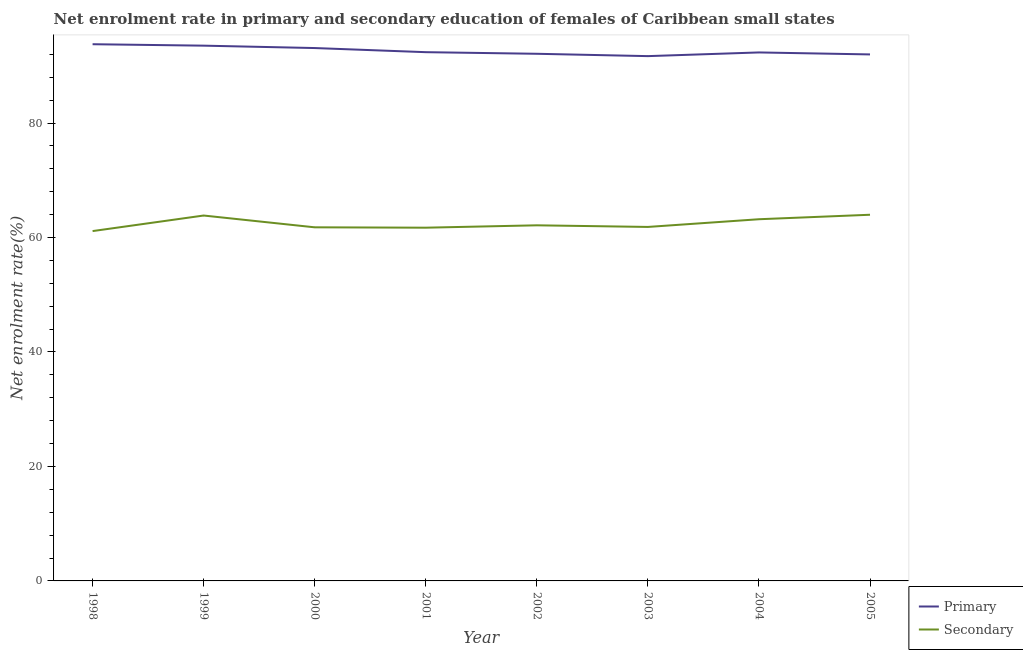Does the line corresponding to enrollment rate in primary education intersect with the line corresponding to enrollment rate in secondary education?
Provide a short and direct response. No. What is the enrollment rate in secondary education in 1999?
Your answer should be very brief. 63.84. Across all years, what is the maximum enrollment rate in primary education?
Provide a short and direct response. 93.77. Across all years, what is the minimum enrollment rate in primary education?
Give a very brief answer. 91.69. In which year was the enrollment rate in primary education maximum?
Provide a succinct answer. 1998. In which year was the enrollment rate in secondary education minimum?
Your response must be concise. 1998. What is the total enrollment rate in secondary education in the graph?
Provide a succinct answer. 499.57. What is the difference between the enrollment rate in primary education in 2004 and that in 2005?
Give a very brief answer. 0.35. What is the difference between the enrollment rate in secondary education in 1999 and the enrollment rate in primary education in 2005?
Your answer should be compact. -28.15. What is the average enrollment rate in primary education per year?
Ensure brevity in your answer.  92.61. In the year 2003, what is the difference between the enrollment rate in primary education and enrollment rate in secondary education?
Give a very brief answer. 29.84. In how many years, is the enrollment rate in primary education greater than 24 %?
Your answer should be compact. 8. What is the ratio of the enrollment rate in secondary education in 2000 to that in 2001?
Your response must be concise. 1. Is the enrollment rate in primary education in 1998 less than that in 2002?
Provide a succinct answer. No. What is the difference between the highest and the second highest enrollment rate in primary education?
Make the answer very short. 0.25. What is the difference between the highest and the lowest enrollment rate in secondary education?
Your answer should be compact. 2.85. Is the sum of the enrollment rate in secondary education in 1999 and 2003 greater than the maximum enrollment rate in primary education across all years?
Provide a succinct answer. Yes. Does the enrollment rate in primary education monotonically increase over the years?
Ensure brevity in your answer.  No. Is the enrollment rate in primary education strictly less than the enrollment rate in secondary education over the years?
Provide a succinct answer. No. How many lines are there?
Make the answer very short. 2. What is the difference between two consecutive major ticks on the Y-axis?
Your answer should be compact. 20. Are the values on the major ticks of Y-axis written in scientific E-notation?
Your response must be concise. No. Where does the legend appear in the graph?
Your response must be concise. Bottom right. What is the title of the graph?
Ensure brevity in your answer.  Net enrolment rate in primary and secondary education of females of Caribbean small states. Does "Long-term debt" appear as one of the legend labels in the graph?
Provide a short and direct response. No. What is the label or title of the X-axis?
Offer a terse response. Year. What is the label or title of the Y-axis?
Your response must be concise. Net enrolment rate(%). What is the Net enrolment rate(%) of Primary in 1998?
Keep it short and to the point. 93.77. What is the Net enrolment rate(%) in Secondary in 1998?
Provide a short and direct response. 61.12. What is the Net enrolment rate(%) of Primary in 1999?
Ensure brevity in your answer.  93.51. What is the Net enrolment rate(%) in Secondary in 1999?
Your answer should be very brief. 63.84. What is the Net enrolment rate(%) in Primary in 2000?
Give a very brief answer. 93.1. What is the Net enrolment rate(%) of Secondary in 2000?
Make the answer very short. 61.78. What is the Net enrolment rate(%) in Primary in 2001?
Offer a terse response. 92.38. What is the Net enrolment rate(%) of Secondary in 2001?
Make the answer very short. 61.71. What is the Net enrolment rate(%) of Primary in 2002?
Your answer should be compact. 92.09. What is the Net enrolment rate(%) in Secondary in 2002?
Your response must be concise. 62.13. What is the Net enrolment rate(%) in Primary in 2003?
Ensure brevity in your answer.  91.69. What is the Net enrolment rate(%) in Secondary in 2003?
Make the answer very short. 61.84. What is the Net enrolment rate(%) of Primary in 2004?
Your answer should be compact. 92.33. What is the Net enrolment rate(%) in Secondary in 2004?
Ensure brevity in your answer.  63.19. What is the Net enrolment rate(%) in Primary in 2005?
Provide a short and direct response. 91.98. What is the Net enrolment rate(%) of Secondary in 2005?
Provide a short and direct response. 63.97. Across all years, what is the maximum Net enrolment rate(%) in Primary?
Your answer should be very brief. 93.77. Across all years, what is the maximum Net enrolment rate(%) of Secondary?
Keep it short and to the point. 63.97. Across all years, what is the minimum Net enrolment rate(%) of Primary?
Provide a short and direct response. 91.69. Across all years, what is the minimum Net enrolment rate(%) in Secondary?
Make the answer very short. 61.12. What is the total Net enrolment rate(%) in Primary in the graph?
Give a very brief answer. 740.84. What is the total Net enrolment rate(%) of Secondary in the graph?
Your answer should be very brief. 499.57. What is the difference between the Net enrolment rate(%) in Primary in 1998 and that in 1999?
Give a very brief answer. 0.25. What is the difference between the Net enrolment rate(%) in Secondary in 1998 and that in 1999?
Keep it short and to the point. -2.72. What is the difference between the Net enrolment rate(%) in Primary in 1998 and that in 2000?
Your response must be concise. 0.67. What is the difference between the Net enrolment rate(%) of Secondary in 1998 and that in 2000?
Your answer should be very brief. -0.66. What is the difference between the Net enrolment rate(%) of Primary in 1998 and that in 2001?
Give a very brief answer. 1.39. What is the difference between the Net enrolment rate(%) of Secondary in 1998 and that in 2001?
Your response must be concise. -0.59. What is the difference between the Net enrolment rate(%) in Primary in 1998 and that in 2002?
Make the answer very short. 1.67. What is the difference between the Net enrolment rate(%) of Secondary in 1998 and that in 2002?
Your response must be concise. -1.01. What is the difference between the Net enrolment rate(%) of Primary in 1998 and that in 2003?
Your response must be concise. 2.08. What is the difference between the Net enrolment rate(%) of Secondary in 1998 and that in 2003?
Your answer should be compact. -0.72. What is the difference between the Net enrolment rate(%) of Primary in 1998 and that in 2004?
Provide a short and direct response. 1.44. What is the difference between the Net enrolment rate(%) in Secondary in 1998 and that in 2004?
Ensure brevity in your answer.  -2.07. What is the difference between the Net enrolment rate(%) of Primary in 1998 and that in 2005?
Your response must be concise. 1.78. What is the difference between the Net enrolment rate(%) in Secondary in 1998 and that in 2005?
Your response must be concise. -2.85. What is the difference between the Net enrolment rate(%) in Primary in 1999 and that in 2000?
Your response must be concise. 0.42. What is the difference between the Net enrolment rate(%) in Secondary in 1999 and that in 2000?
Your answer should be very brief. 2.06. What is the difference between the Net enrolment rate(%) of Primary in 1999 and that in 2001?
Your response must be concise. 1.14. What is the difference between the Net enrolment rate(%) of Secondary in 1999 and that in 2001?
Your answer should be compact. 2.12. What is the difference between the Net enrolment rate(%) of Primary in 1999 and that in 2002?
Offer a terse response. 1.42. What is the difference between the Net enrolment rate(%) of Secondary in 1999 and that in 2002?
Offer a terse response. 1.71. What is the difference between the Net enrolment rate(%) in Primary in 1999 and that in 2003?
Offer a terse response. 1.83. What is the difference between the Net enrolment rate(%) in Secondary in 1999 and that in 2003?
Ensure brevity in your answer.  1.99. What is the difference between the Net enrolment rate(%) in Primary in 1999 and that in 2004?
Offer a terse response. 1.19. What is the difference between the Net enrolment rate(%) in Secondary in 1999 and that in 2004?
Your response must be concise. 0.65. What is the difference between the Net enrolment rate(%) in Primary in 1999 and that in 2005?
Give a very brief answer. 1.53. What is the difference between the Net enrolment rate(%) in Secondary in 1999 and that in 2005?
Provide a short and direct response. -0.14. What is the difference between the Net enrolment rate(%) of Primary in 2000 and that in 2001?
Offer a very short reply. 0.72. What is the difference between the Net enrolment rate(%) in Secondary in 2000 and that in 2001?
Give a very brief answer. 0.06. What is the difference between the Net enrolment rate(%) in Primary in 2000 and that in 2002?
Offer a very short reply. 1. What is the difference between the Net enrolment rate(%) of Secondary in 2000 and that in 2002?
Make the answer very short. -0.35. What is the difference between the Net enrolment rate(%) in Primary in 2000 and that in 2003?
Offer a very short reply. 1.41. What is the difference between the Net enrolment rate(%) in Secondary in 2000 and that in 2003?
Keep it short and to the point. -0.07. What is the difference between the Net enrolment rate(%) in Primary in 2000 and that in 2004?
Provide a succinct answer. 0.77. What is the difference between the Net enrolment rate(%) of Secondary in 2000 and that in 2004?
Keep it short and to the point. -1.41. What is the difference between the Net enrolment rate(%) in Primary in 2000 and that in 2005?
Give a very brief answer. 1.11. What is the difference between the Net enrolment rate(%) of Secondary in 2000 and that in 2005?
Make the answer very short. -2.2. What is the difference between the Net enrolment rate(%) in Primary in 2001 and that in 2002?
Your answer should be compact. 0.28. What is the difference between the Net enrolment rate(%) in Secondary in 2001 and that in 2002?
Give a very brief answer. -0.42. What is the difference between the Net enrolment rate(%) of Primary in 2001 and that in 2003?
Your answer should be compact. 0.69. What is the difference between the Net enrolment rate(%) of Secondary in 2001 and that in 2003?
Your answer should be compact. -0.13. What is the difference between the Net enrolment rate(%) of Primary in 2001 and that in 2004?
Give a very brief answer. 0.05. What is the difference between the Net enrolment rate(%) in Secondary in 2001 and that in 2004?
Give a very brief answer. -1.48. What is the difference between the Net enrolment rate(%) in Primary in 2001 and that in 2005?
Ensure brevity in your answer.  0.39. What is the difference between the Net enrolment rate(%) of Secondary in 2001 and that in 2005?
Give a very brief answer. -2.26. What is the difference between the Net enrolment rate(%) of Primary in 2002 and that in 2003?
Your response must be concise. 0.41. What is the difference between the Net enrolment rate(%) in Secondary in 2002 and that in 2003?
Provide a short and direct response. 0.28. What is the difference between the Net enrolment rate(%) in Primary in 2002 and that in 2004?
Your answer should be compact. -0.23. What is the difference between the Net enrolment rate(%) in Secondary in 2002 and that in 2004?
Your response must be concise. -1.06. What is the difference between the Net enrolment rate(%) in Primary in 2002 and that in 2005?
Provide a succinct answer. 0.11. What is the difference between the Net enrolment rate(%) in Secondary in 2002 and that in 2005?
Offer a terse response. -1.85. What is the difference between the Net enrolment rate(%) in Primary in 2003 and that in 2004?
Give a very brief answer. -0.64. What is the difference between the Net enrolment rate(%) in Secondary in 2003 and that in 2004?
Your answer should be compact. -1.35. What is the difference between the Net enrolment rate(%) in Primary in 2003 and that in 2005?
Your answer should be very brief. -0.3. What is the difference between the Net enrolment rate(%) of Secondary in 2003 and that in 2005?
Keep it short and to the point. -2.13. What is the difference between the Net enrolment rate(%) of Primary in 2004 and that in 2005?
Provide a succinct answer. 0.35. What is the difference between the Net enrolment rate(%) in Secondary in 2004 and that in 2005?
Make the answer very short. -0.78. What is the difference between the Net enrolment rate(%) in Primary in 1998 and the Net enrolment rate(%) in Secondary in 1999?
Your answer should be compact. 29.93. What is the difference between the Net enrolment rate(%) of Primary in 1998 and the Net enrolment rate(%) of Secondary in 2000?
Provide a short and direct response. 31.99. What is the difference between the Net enrolment rate(%) of Primary in 1998 and the Net enrolment rate(%) of Secondary in 2001?
Keep it short and to the point. 32.05. What is the difference between the Net enrolment rate(%) in Primary in 1998 and the Net enrolment rate(%) in Secondary in 2002?
Provide a succinct answer. 31.64. What is the difference between the Net enrolment rate(%) in Primary in 1998 and the Net enrolment rate(%) in Secondary in 2003?
Your answer should be very brief. 31.92. What is the difference between the Net enrolment rate(%) of Primary in 1998 and the Net enrolment rate(%) of Secondary in 2004?
Provide a succinct answer. 30.58. What is the difference between the Net enrolment rate(%) in Primary in 1998 and the Net enrolment rate(%) in Secondary in 2005?
Your answer should be compact. 29.79. What is the difference between the Net enrolment rate(%) of Primary in 1999 and the Net enrolment rate(%) of Secondary in 2000?
Provide a short and direct response. 31.74. What is the difference between the Net enrolment rate(%) in Primary in 1999 and the Net enrolment rate(%) in Secondary in 2001?
Offer a very short reply. 31.8. What is the difference between the Net enrolment rate(%) in Primary in 1999 and the Net enrolment rate(%) in Secondary in 2002?
Make the answer very short. 31.39. What is the difference between the Net enrolment rate(%) of Primary in 1999 and the Net enrolment rate(%) of Secondary in 2003?
Make the answer very short. 31.67. What is the difference between the Net enrolment rate(%) in Primary in 1999 and the Net enrolment rate(%) in Secondary in 2004?
Keep it short and to the point. 30.32. What is the difference between the Net enrolment rate(%) of Primary in 1999 and the Net enrolment rate(%) of Secondary in 2005?
Make the answer very short. 29.54. What is the difference between the Net enrolment rate(%) of Primary in 2000 and the Net enrolment rate(%) of Secondary in 2001?
Offer a terse response. 31.39. What is the difference between the Net enrolment rate(%) of Primary in 2000 and the Net enrolment rate(%) of Secondary in 2002?
Your response must be concise. 30.97. What is the difference between the Net enrolment rate(%) in Primary in 2000 and the Net enrolment rate(%) in Secondary in 2003?
Provide a succinct answer. 31.25. What is the difference between the Net enrolment rate(%) in Primary in 2000 and the Net enrolment rate(%) in Secondary in 2004?
Provide a succinct answer. 29.91. What is the difference between the Net enrolment rate(%) of Primary in 2000 and the Net enrolment rate(%) of Secondary in 2005?
Keep it short and to the point. 29.12. What is the difference between the Net enrolment rate(%) of Primary in 2001 and the Net enrolment rate(%) of Secondary in 2002?
Make the answer very short. 30.25. What is the difference between the Net enrolment rate(%) in Primary in 2001 and the Net enrolment rate(%) in Secondary in 2003?
Offer a very short reply. 30.53. What is the difference between the Net enrolment rate(%) in Primary in 2001 and the Net enrolment rate(%) in Secondary in 2004?
Provide a short and direct response. 29.19. What is the difference between the Net enrolment rate(%) of Primary in 2001 and the Net enrolment rate(%) of Secondary in 2005?
Provide a short and direct response. 28.4. What is the difference between the Net enrolment rate(%) in Primary in 2002 and the Net enrolment rate(%) in Secondary in 2003?
Your answer should be compact. 30.25. What is the difference between the Net enrolment rate(%) of Primary in 2002 and the Net enrolment rate(%) of Secondary in 2004?
Your response must be concise. 28.9. What is the difference between the Net enrolment rate(%) in Primary in 2002 and the Net enrolment rate(%) in Secondary in 2005?
Offer a terse response. 28.12. What is the difference between the Net enrolment rate(%) in Primary in 2003 and the Net enrolment rate(%) in Secondary in 2004?
Make the answer very short. 28.5. What is the difference between the Net enrolment rate(%) of Primary in 2003 and the Net enrolment rate(%) of Secondary in 2005?
Your answer should be compact. 27.71. What is the difference between the Net enrolment rate(%) in Primary in 2004 and the Net enrolment rate(%) in Secondary in 2005?
Your response must be concise. 28.36. What is the average Net enrolment rate(%) in Primary per year?
Give a very brief answer. 92.61. What is the average Net enrolment rate(%) of Secondary per year?
Your response must be concise. 62.45. In the year 1998, what is the difference between the Net enrolment rate(%) of Primary and Net enrolment rate(%) of Secondary?
Your answer should be very brief. 32.65. In the year 1999, what is the difference between the Net enrolment rate(%) of Primary and Net enrolment rate(%) of Secondary?
Keep it short and to the point. 29.68. In the year 2000, what is the difference between the Net enrolment rate(%) of Primary and Net enrolment rate(%) of Secondary?
Your answer should be compact. 31.32. In the year 2001, what is the difference between the Net enrolment rate(%) in Primary and Net enrolment rate(%) in Secondary?
Provide a succinct answer. 30.66. In the year 2002, what is the difference between the Net enrolment rate(%) of Primary and Net enrolment rate(%) of Secondary?
Make the answer very short. 29.97. In the year 2003, what is the difference between the Net enrolment rate(%) in Primary and Net enrolment rate(%) in Secondary?
Make the answer very short. 29.84. In the year 2004, what is the difference between the Net enrolment rate(%) of Primary and Net enrolment rate(%) of Secondary?
Your answer should be compact. 29.14. In the year 2005, what is the difference between the Net enrolment rate(%) in Primary and Net enrolment rate(%) in Secondary?
Keep it short and to the point. 28.01. What is the ratio of the Net enrolment rate(%) in Primary in 1998 to that in 1999?
Ensure brevity in your answer.  1. What is the ratio of the Net enrolment rate(%) of Secondary in 1998 to that in 1999?
Make the answer very short. 0.96. What is the ratio of the Net enrolment rate(%) of Primary in 1998 to that in 2000?
Ensure brevity in your answer.  1.01. What is the ratio of the Net enrolment rate(%) of Secondary in 1998 to that in 2000?
Your answer should be compact. 0.99. What is the ratio of the Net enrolment rate(%) in Primary in 1998 to that in 2002?
Make the answer very short. 1.02. What is the ratio of the Net enrolment rate(%) of Secondary in 1998 to that in 2002?
Your answer should be compact. 0.98. What is the ratio of the Net enrolment rate(%) in Primary in 1998 to that in 2003?
Make the answer very short. 1.02. What is the ratio of the Net enrolment rate(%) in Secondary in 1998 to that in 2003?
Keep it short and to the point. 0.99. What is the ratio of the Net enrolment rate(%) in Primary in 1998 to that in 2004?
Provide a succinct answer. 1.02. What is the ratio of the Net enrolment rate(%) in Secondary in 1998 to that in 2004?
Keep it short and to the point. 0.97. What is the ratio of the Net enrolment rate(%) in Primary in 1998 to that in 2005?
Make the answer very short. 1.02. What is the ratio of the Net enrolment rate(%) of Secondary in 1998 to that in 2005?
Offer a very short reply. 0.96. What is the ratio of the Net enrolment rate(%) in Primary in 1999 to that in 2000?
Offer a very short reply. 1. What is the ratio of the Net enrolment rate(%) in Secondary in 1999 to that in 2000?
Make the answer very short. 1.03. What is the ratio of the Net enrolment rate(%) of Primary in 1999 to that in 2001?
Offer a terse response. 1.01. What is the ratio of the Net enrolment rate(%) in Secondary in 1999 to that in 2001?
Keep it short and to the point. 1.03. What is the ratio of the Net enrolment rate(%) in Primary in 1999 to that in 2002?
Offer a terse response. 1.02. What is the ratio of the Net enrolment rate(%) of Secondary in 1999 to that in 2002?
Your answer should be very brief. 1.03. What is the ratio of the Net enrolment rate(%) in Primary in 1999 to that in 2003?
Offer a terse response. 1.02. What is the ratio of the Net enrolment rate(%) in Secondary in 1999 to that in 2003?
Give a very brief answer. 1.03. What is the ratio of the Net enrolment rate(%) of Primary in 1999 to that in 2004?
Your response must be concise. 1.01. What is the ratio of the Net enrolment rate(%) of Secondary in 1999 to that in 2004?
Ensure brevity in your answer.  1.01. What is the ratio of the Net enrolment rate(%) in Primary in 1999 to that in 2005?
Give a very brief answer. 1.02. What is the ratio of the Net enrolment rate(%) in Primary in 2000 to that in 2001?
Give a very brief answer. 1.01. What is the ratio of the Net enrolment rate(%) in Secondary in 2000 to that in 2001?
Your response must be concise. 1. What is the ratio of the Net enrolment rate(%) in Primary in 2000 to that in 2002?
Give a very brief answer. 1.01. What is the ratio of the Net enrolment rate(%) of Primary in 2000 to that in 2003?
Your answer should be very brief. 1.02. What is the ratio of the Net enrolment rate(%) of Primary in 2000 to that in 2004?
Make the answer very short. 1.01. What is the ratio of the Net enrolment rate(%) in Secondary in 2000 to that in 2004?
Keep it short and to the point. 0.98. What is the ratio of the Net enrolment rate(%) of Primary in 2000 to that in 2005?
Keep it short and to the point. 1.01. What is the ratio of the Net enrolment rate(%) of Secondary in 2000 to that in 2005?
Give a very brief answer. 0.97. What is the ratio of the Net enrolment rate(%) in Primary in 2001 to that in 2003?
Give a very brief answer. 1.01. What is the ratio of the Net enrolment rate(%) of Secondary in 2001 to that in 2003?
Ensure brevity in your answer.  1. What is the ratio of the Net enrolment rate(%) in Secondary in 2001 to that in 2004?
Provide a short and direct response. 0.98. What is the ratio of the Net enrolment rate(%) of Primary in 2001 to that in 2005?
Provide a short and direct response. 1. What is the ratio of the Net enrolment rate(%) of Secondary in 2001 to that in 2005?
Your answer should be compact. 0.96. What is the ratio of the Net enrolment rate(%) in Primary in 2002 to that in 2003?
Your answer should be very brief. 1. What is the ratio of the Net enrolment rate(%) in Secondary in 2002 to that in 2004?
Give a very brief answer. 0.98. What is the ratio of the Net enrolment rate(%) of Secondary in 2002 to that in 2005?
Give a very brief answer. 0.97. What is the ratio of the Net enrolment rate(%) of Primary in 2003 to that in 2004?
Offer a terse response. 0.99. What is the ratio of the Net enrolment rate(%) of Secondary in 2003 to that in 2004?
Offer a very short reply. 0.98. What is the ratio of the Net enrolment rate(%) in Secondary in 2003 to that in 2005?
Provide a succinct answer. 0.97. What is the ratio of the Net enrolment rate(%) of Primary in 2004 to that in 2005?
Your response must be concise. 1. What is the ratio of the Net enrolment rate(%) in Secondary in 2004 to that in 2005?
Provide a short and direct response. 0.99. What is the difference between the highest and the second highest Net enrolment rate(%) in Primary?
Provide a succinct answer. 0.25. What is the difference between the highest and the second highest Net enrolment rate(%) in Secondary?
Offer a very short reply. 0.14. What is the difference between the highest and the lowest Net enrolment rate(%) in Primary?
Provide a succinct answer. 2.08. What is the difference between the highest and the lowest Net enrolment rate(%) of Secondary?
Your answer should be very brief. 2.85. 